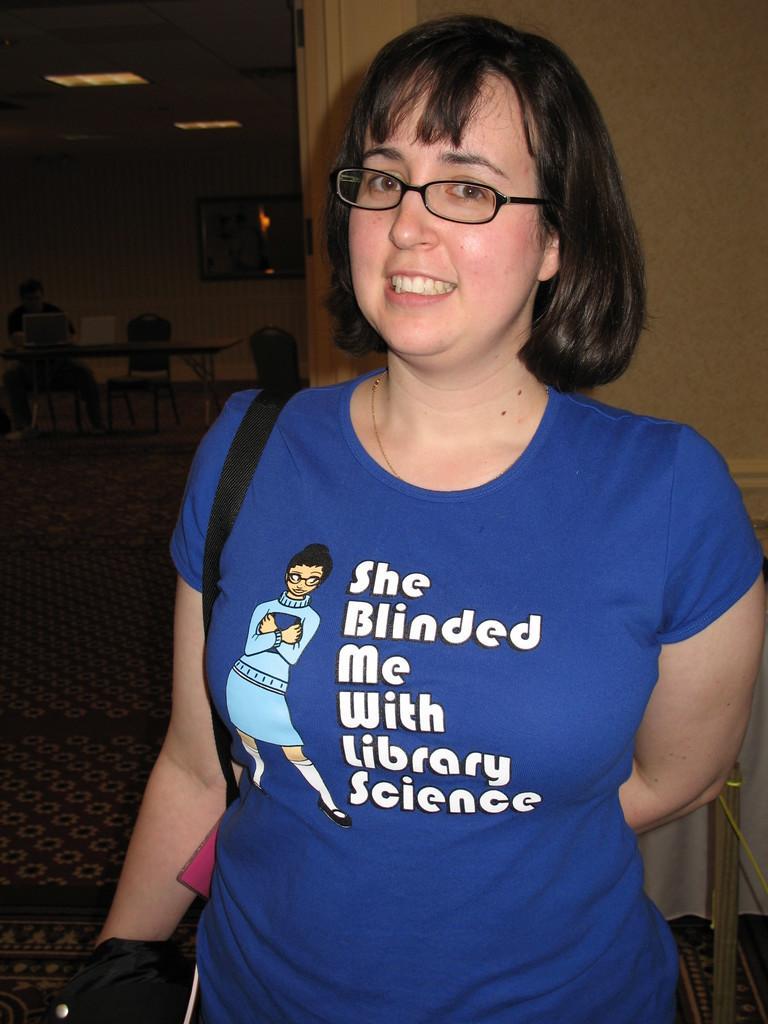Can you describe this image briefly? In this picture I can see a woman, who is standing and I see that she is wearing a blue color t-shirt on which something is written and in the background I see few chairs and a table and I see another person and I see the lights on the ceiling 